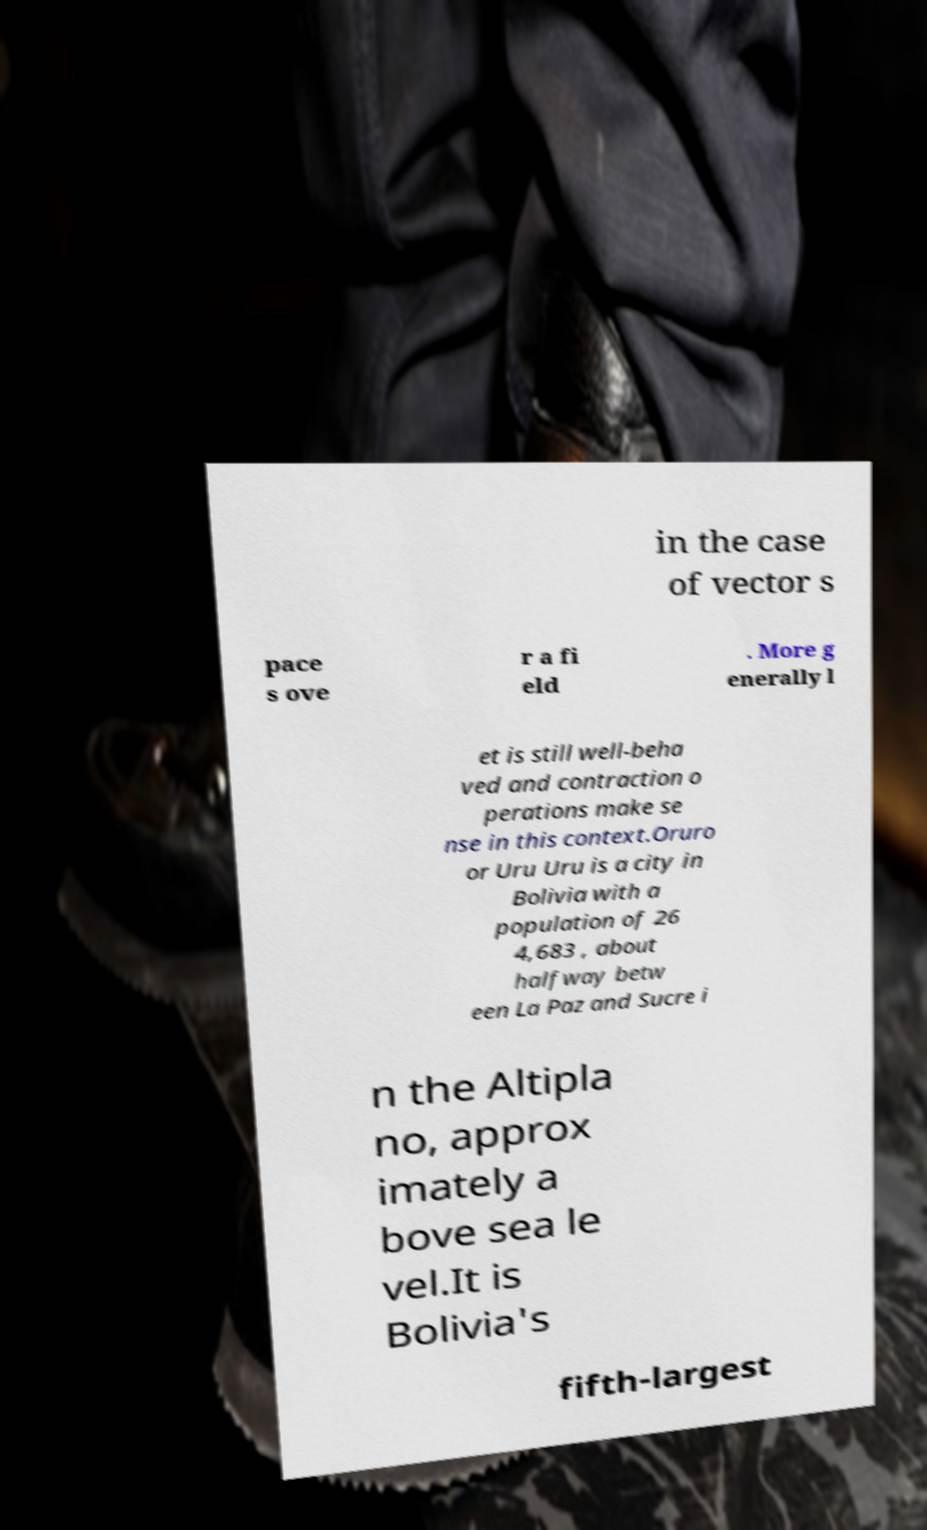Could you assist in decoding the text presented in this image and type it out clearly? in the case of vector s pace s ove r a fi eld . More g enerally l et is still well-beha ved and contraction o perations make se nse in this context.Oruro or Uru Uru is a city in Bolivia with a population of 26 4,683 , about halfway betw een La Paz and Sucre i n the Altipla no, approx imately a bove sea le vel.It is Bolivia's fifth-largest 